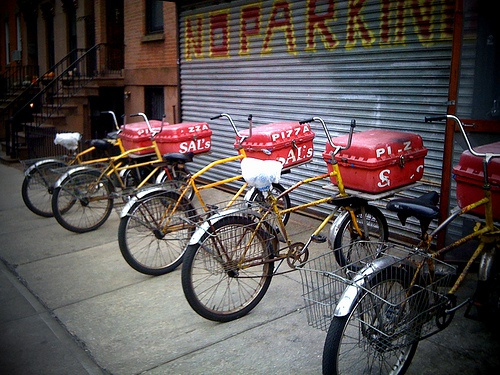Describe the objects in this image and their specific colors. I can see bicycle in black, darkgray, gray, and maroon tones, bicycle in black, gray, and darkgray tones, bicycle in black, darkgray, gray, and white tones, bicycle in black, gray, and maroon tones, and bicycle in black, gray, lavender, and maroon tones in this image. 